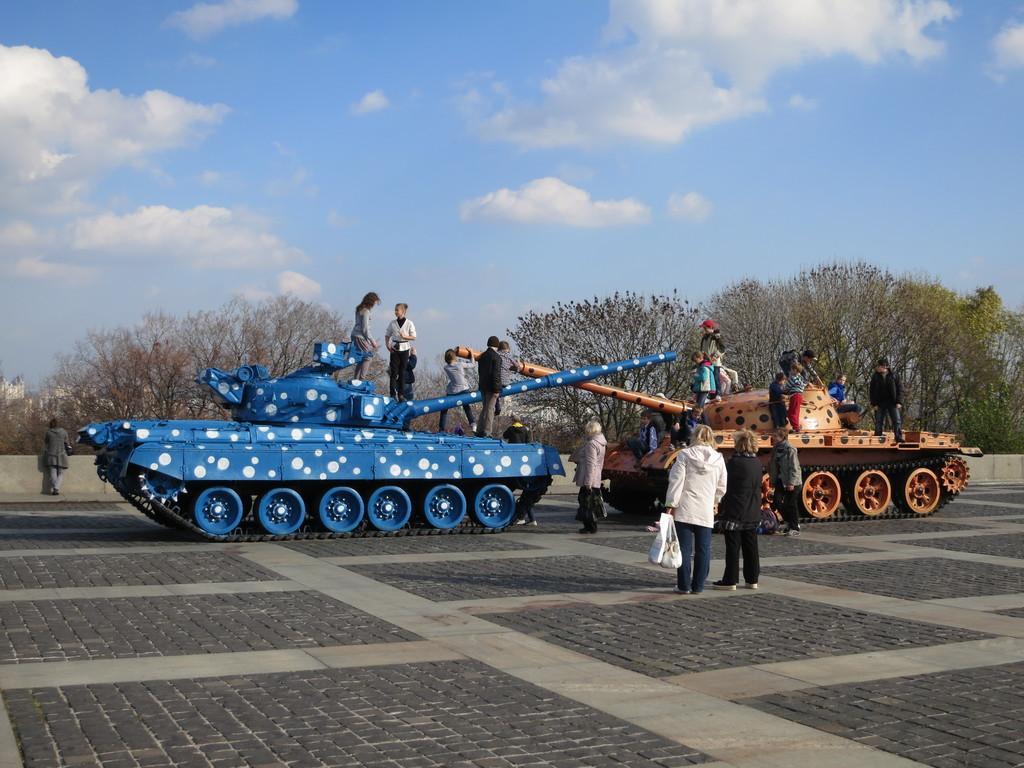Can you describe this image briefly? In this image, we can see two battle tanks. There are some people standing, we can see some trees. At the top we can see the sky. 